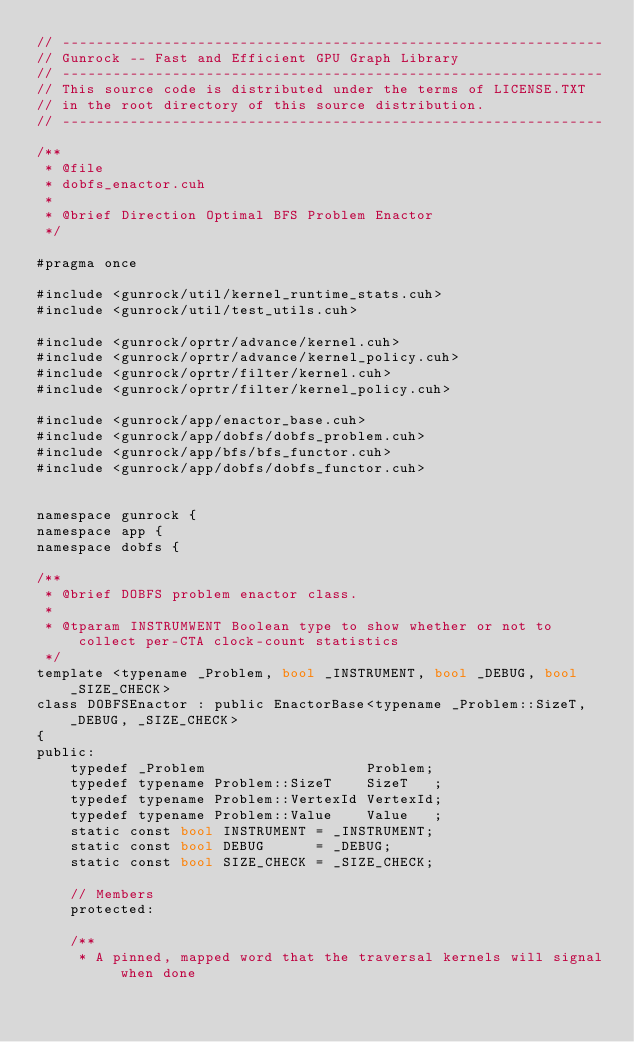Convert code to text. <code><loc_0><loc_0><loc_500><loc_500><_Cuda_>// ----------------------------------------------------------------
// Gunrock -- Fast and Efficient GPU Graph Library
// ----------------------------------------------------------------
// This source code is distributed under the terms of LICENSE.TXT
// in the root directory of this source distribution.
// ----------------------------------------------------------------

/**
 * @file
 * dobfs_enactor.cuh
 *
 * @brief Direction Optimal BFS Problem Enactor
 */

#pragma once

#include <gunrock/util/kernel_runtime_stats.cuh>
#include <gunrock/util/test_utils.cuh>

#include <gunrock/oprtr/advance/kernel.cuh>
#include <gunrock/oprtr/advance/kernel_policy.cuh>
#include <gunrock/oprtr/filter/kernel.cuh>
#include <gunrock/oprtr/filter/kernel_policy.cuh>

#include <gunrock/app/enactor_base.cuh>
#include <gunrock/app/dobfs/dobfs_problem.cuh>
#include <gunrock/app/bfs/bfs_functor.cuh>
#include <gunrock/app/dobfs/dobfs_functor.cuh>


namespace gunrock {
namespace app {
namespace dobfs {

/**
 * @brief DOBFS problem enactor class.
 *
 * @tparam INSTRUMWENT Boolean type to show whether or not to collect per-CTA clock-count statistics
 */
template <typename _Problem, bool _INSTRUMENT, bool _DEBUG, bool _SIZE_CHECK>
class DOBFSEnactor : public EnactorBase<typename _Problem::SizeT, _DEBUG, _SIZE_CHECK>
{
public:
    typedef _Problem                   Problem;
    typedef typename Problem::SizeT    SizeT   ;
    typedef typename Problem::VertexId VertexId;
    typedef typename Problem::Value    Value   ;
    static const bool INSTRUMENT = _INSTRUMENT;
    static const bool DEBUG      = _DEBUG;
    static const bool SIZE_CHECK = _SIZE_CHECK;

    // Members
    protected:

    /**
     * A pinned, mapped word that the traversal kernels will signal when done</code> 